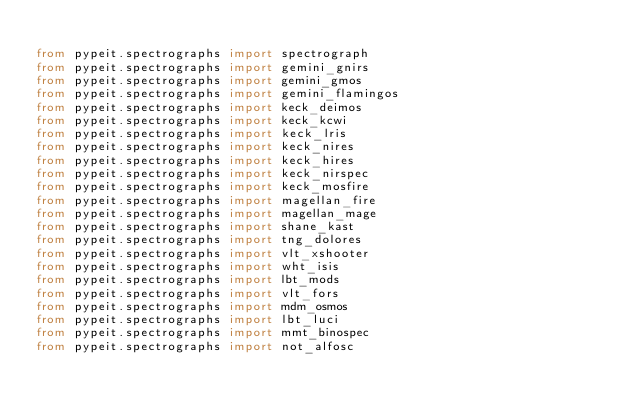Convert code to text. <code><loc_0><loc_0><loc_500><loc_500><_Python_>
from pypeit.spectrographs import spectrograph
from pypeit.spectrographs import gemini_gnirs
from pypeit.spectrographs import gemini_gmos
from pypeit.spectrographs import gemini_flamingos
from pypeit.spectrographs import keck_deimos
from pypeit.spectrographs import keck_kcwi
from pypeit.spectrographs import keck_lris
from pypeit.spectrographs import keck_nires
from pypeit.spectrographs import keck_hires
from pypeit.spectrographs import keck_nirspec
from pypeit.spectrographs import keck_mosfire
from pypeit.spectrographs import magellan_fire
from pypeit.spectrographs import magellan_mage
from pypeit.spectrographs import shane_kast
from pypeit.spectrographs import tng_dolores
from pypeit.spectrographs import vlt_xshooter
from pypeit.spectrographs import wht_isis
from pypeit.spectrographs import lbt_mods
from pypeit.spectrographs import vlt_fors
from pypeit.spectrographs import mdm_osmos
from pypeit.spectrographs import lbt_luci
from pypeit.spectrographs import mmt_binospec
from pypeit.spectrographs import not_alfosc
</code> 